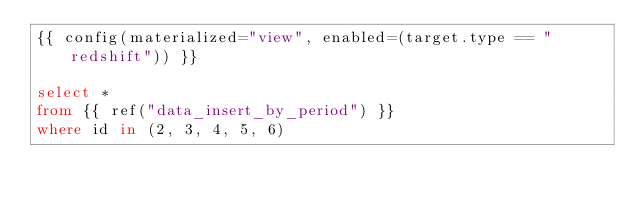<code> <loc_0><loc_0><loc_500><loc_500><_SQL_>{{ config(materialized="view", enabled=(target.type == "redshift")) }}

select *
from {{ ref("data_insert_by_period") }}
where id in (2, 3, 4, 5, 6)
</code> 